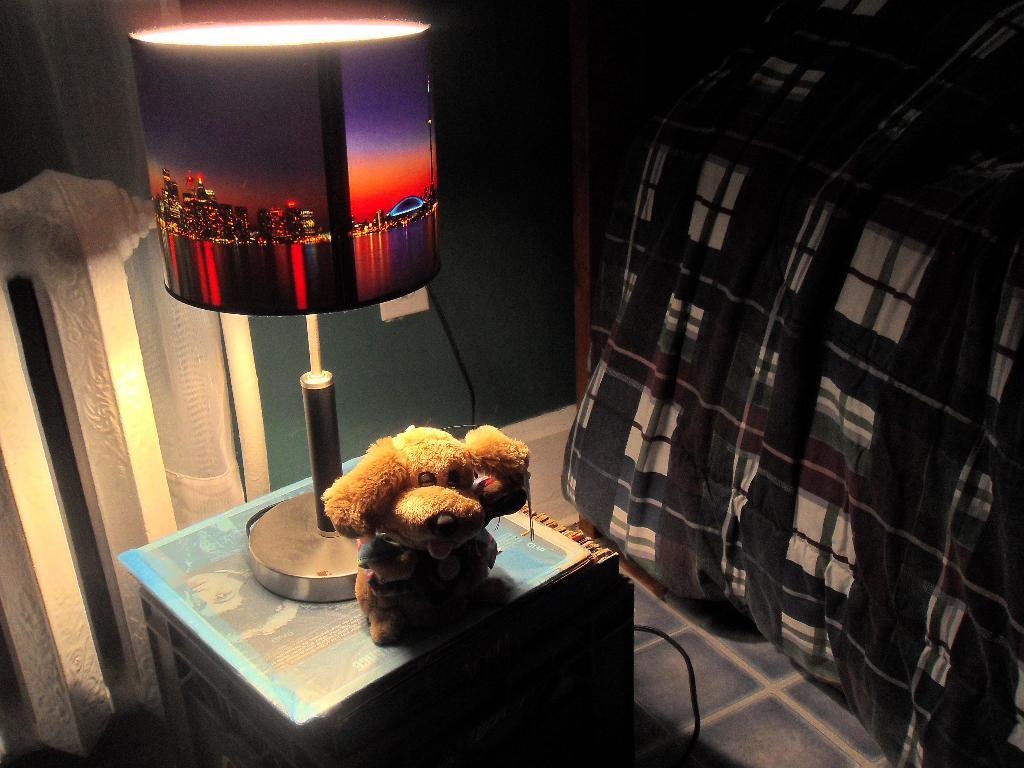What object is located in the foreground of the image? There is a toy in the foreground of the image. What other object can be seen on the table in the foreground? There is a lamp on the table in the foreground. What type of furniture is visible on the right side of the image? It appears there is a bed on the right side of the image. What is visible in the background of the image? There is a wall visible in the background of the image. What type of bean is being traded in the image? There is no bean or trade activity present in the image. Is there any payment being made in the image? There is no payment or financial transaction depicted in the image. 